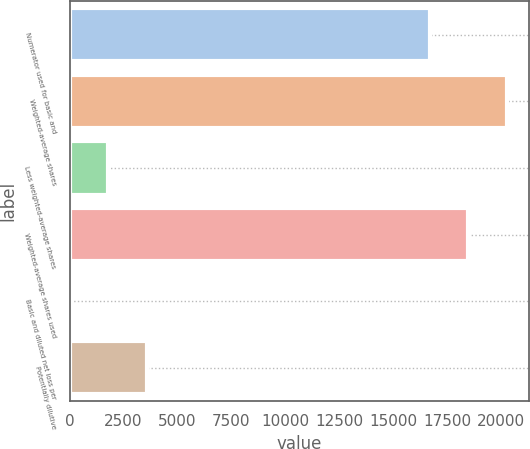Convert chart to OTSL. <chart><loc_0><loc_0><loc_500><loc_500><bar_chart><fcel>Numerator used for basic and<fcel>Weighted-average shares<fcel>Less weighted-average shares<fcel>Weighted-average shares used<fcel>Basic and diluted net loss per<fcel>Potentially dilutive<nl><fcel>16700<fcel>20299<fcel>1800.44<fcel>18499.5<fcel>0.93<fcel>3599.95<nl></chart> 